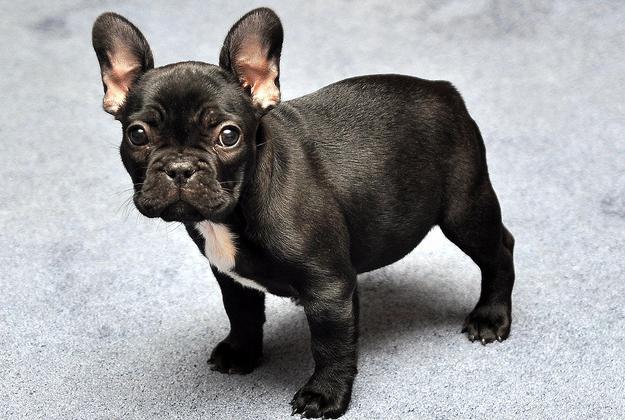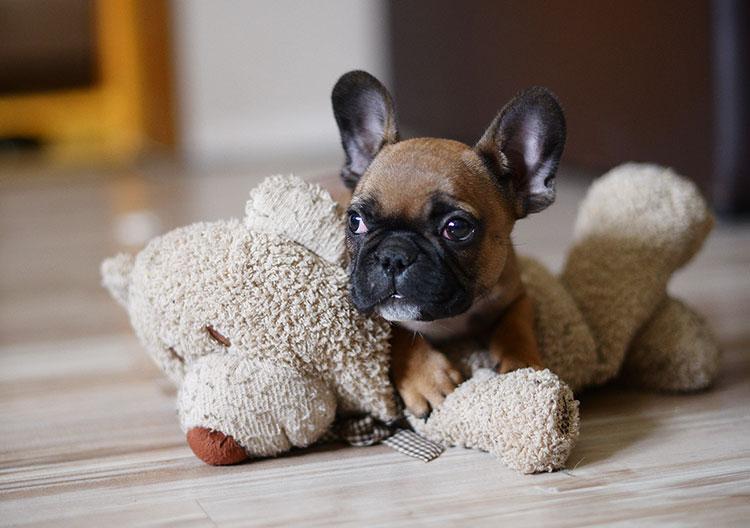The first image is the image on the left, the second image is the image on the right. Examine the images to the left and right. Is the description "One of the dogs has its head resting directly on a cushion." accurate? Answer yes or no. No. The first image is the image on the left, the second image is the image on the right. Given the left and right images, does the statement "There is one dog lying on a wood floor." hold true? Answer yes or no. Yes. 